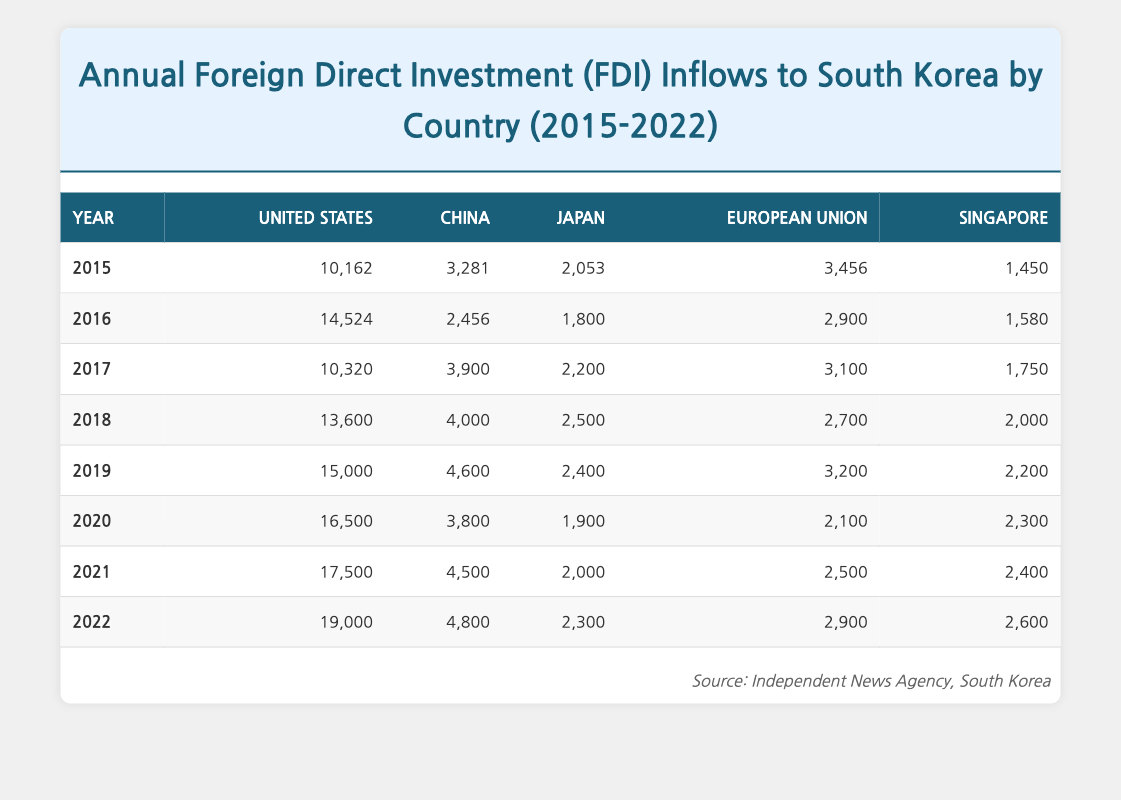What was the FDI inflow from the United States in 2019? In the table, locate the row for the year 2019 and look under the column for the United States. The value listed is 15,000.
Answer: 15,000 Which country had the second highest FDI inflow in 2021? For 2021, examine all countries' FDI inflows. The United States has the highest at 17,500, followed by China at 4,500, which is the second highest.
Answer: China What is the total FDI inflow from China over the years 2015 to 2022? Adding the values from the China column: 3,281 (2015) + 2,456 (2016) + 3,900 (2017) + 4,000 (2018) + 4,600 (2019) + 3,800 (2020) + 4,500 (2021) + 4,800 (2022) results in a total of 31,337.
Answer: 31,337 Did the FDI inflow from Japan increase every year from 2015 to 2022? Review the Japan column for yearly values: 2,053 (2015), 1,800 (2016), 2,200 (2017), 2,500 (2018), 2,400 (2019), 1,900 (2020), 2,000 (2021), 2,300 (2022). The values do not consistently increase as they drop in 2016, 2020, and 2019.
Answer: No What was the average annual FDI inflow from the European Union over the years listed? Add the EU inflows: 3,456 (2015) + 2,900 (2016) + 3,100 (2017) + 2,700 (2018) + 3,200 (2019) + 2,100 (2020) + 2,500 (2021) + 2,900 (2022) totaling 23,456. Divide by 8 years to get the average, which is 2,932.
Answer: 2,932 Which year had the highest overall FDI inflow from all countries combined? Calculate the total FDI inflows for each year: for instance, 2015 = 10,162 + 3,281 + 2,053 + 3,456 + 1,450 = 20,402. Perform this for each year; 2021 shows the highest total inflow at 43,700.
Answer: 2021 What was the FDI inflow from Singapore in 2020? Look in the Singapore column for the year 2020. The value is 2,300.
Answer: 2,300 Is the FDI inflow from the United States consistently higher than that from China from 2015 to 2022? Compare yearly values from the table for both countries. In each year, the United States has a higher FDI inflow than China.
Answer: Yes 